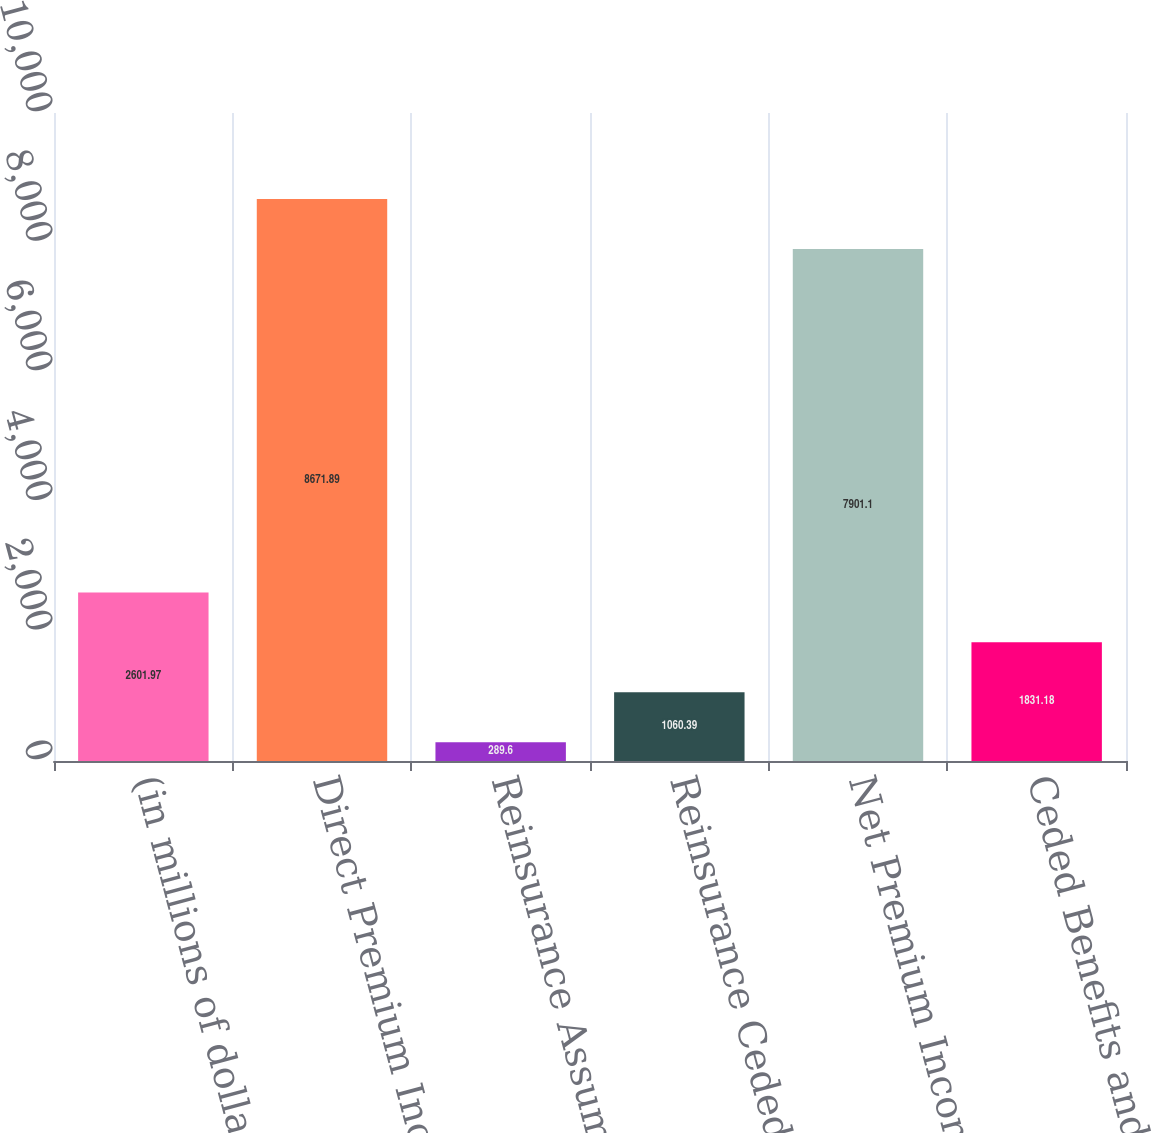<chart> <loc_0><loc_0><loc_500><loc_500><bar_chart><fcel>(in millions of dollars)<fcel>Direct Premium Income<fcel>Reinsurance Assumed<fcel>Reinsurance Ceded<fcel>Net Premium Income<fcel>Ceded Benefits and Change in<nl><fcel>2601.97<fcel>8671.89<fcel>289.6<fcel>1060.39<fcel>7901.1<fcel>1831.18<nl></chart> 